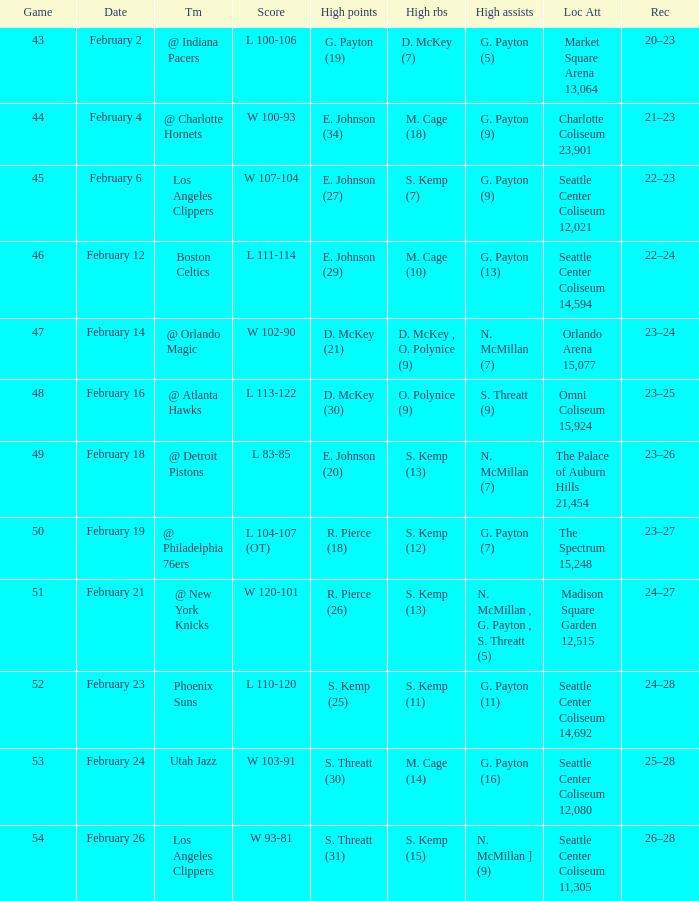What is the record for the Utah Jazz? 25–28. 